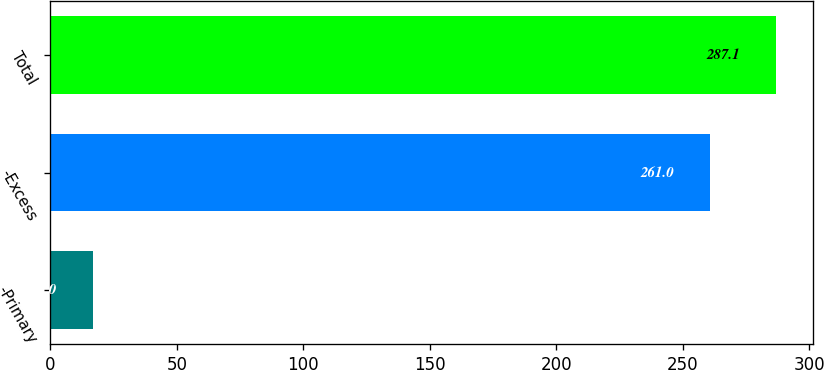Convert chart. <chart><loc_0><loc_0><loc_500><loc_500><bar_chart><fcel>-Primary<fcel>-Excess<fcel>Total<nl><fcel>17<fcel>261<fcel>287.1<nl></chart> 